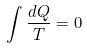Convert formula to latex. <formula><loc_0><loc_0><loc_500><loc_500>\int \frac { d Q } { T } = 0</formula> 